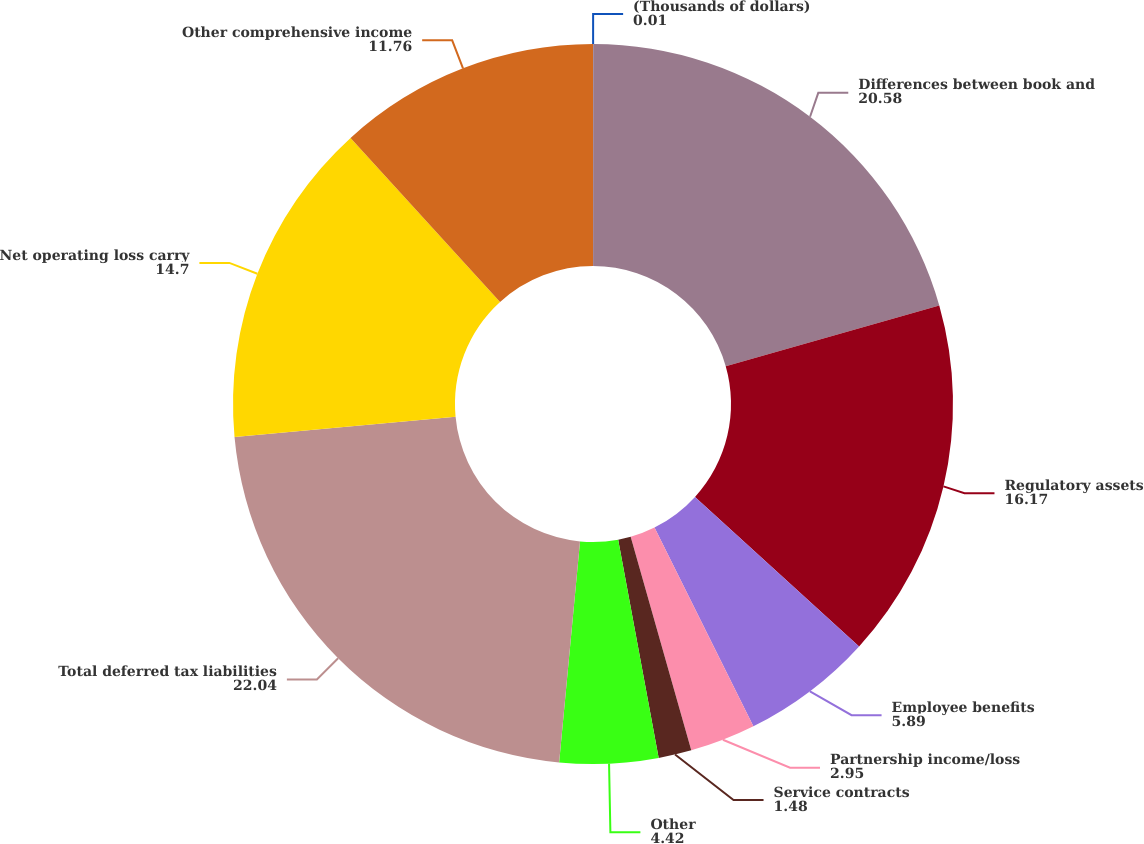Convert chart. <chart><loc_0><loc_0><loc_500><loc_500><pie_chart><fcel>(Thousands of dollars)<fcel>Differences between book and<fcel>Regulatory assets<fcel>Employee benefits<fcel>Partnership income/loss<fcel>Service contracts<fcel>Other<fcel>Total deferred tax liabilities<fcel>Net operating loss carry<fcel>Other comprehensive income<nl><fcel>0.01%<fcel>20.58%<fcel>16.17%<fcel>5.89%<fcel>2.95%<fcel>1.48%<fcel>4.42%<fcel>22.04%<fcel>14.7%<fcel>11.76%<nl></chart> 